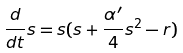Convert formula to latex. <formula><loc_0><loc_0><loc_500><loc_500>\frac { d } { d t } s = s ( s + \frac { \alpha ^ { \prime } } { 4 } s ^ { 2 } - r )</formula> 